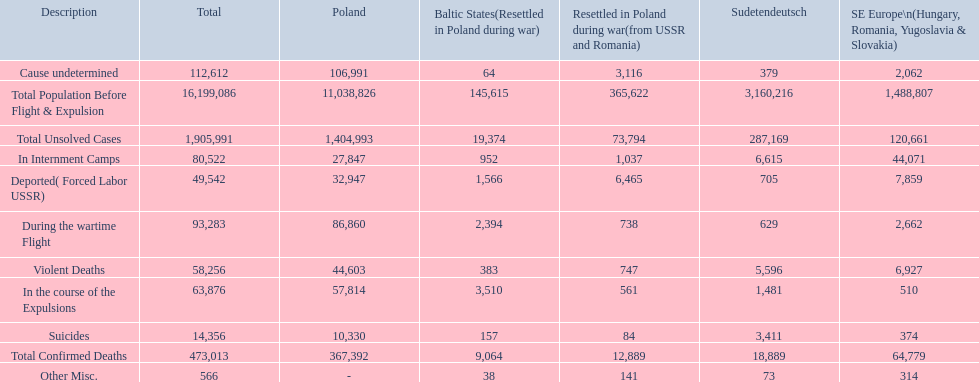What were the total number of confirmed deaths? 473,013. Of these, how many were violent? 58,256. 